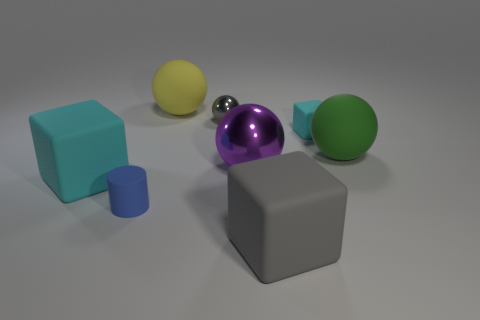Subtract 2 spheres. How many spheres are left? 2 Subtract all yellow matte spheres. How many spheres are left? 3 Subtract all purple spheres. How many spheres are left? 3 Subtract all blue balls. Subtract all green cylinders. How many balls are left? 4 Add 1 cyan balls. How many objects exist? 9 Subtract all blocks. How many objects are left? 5 Add 3 large cyan things. How many large cyan things exist? 4 Subtract 0 gray cylinders. How many objects are left? 8 Subtract all gray matte blocks. Subtract all tiny gray balls. How many objects are left? 6 Add 3 big matte balls. How many big matte balls are left? 5 